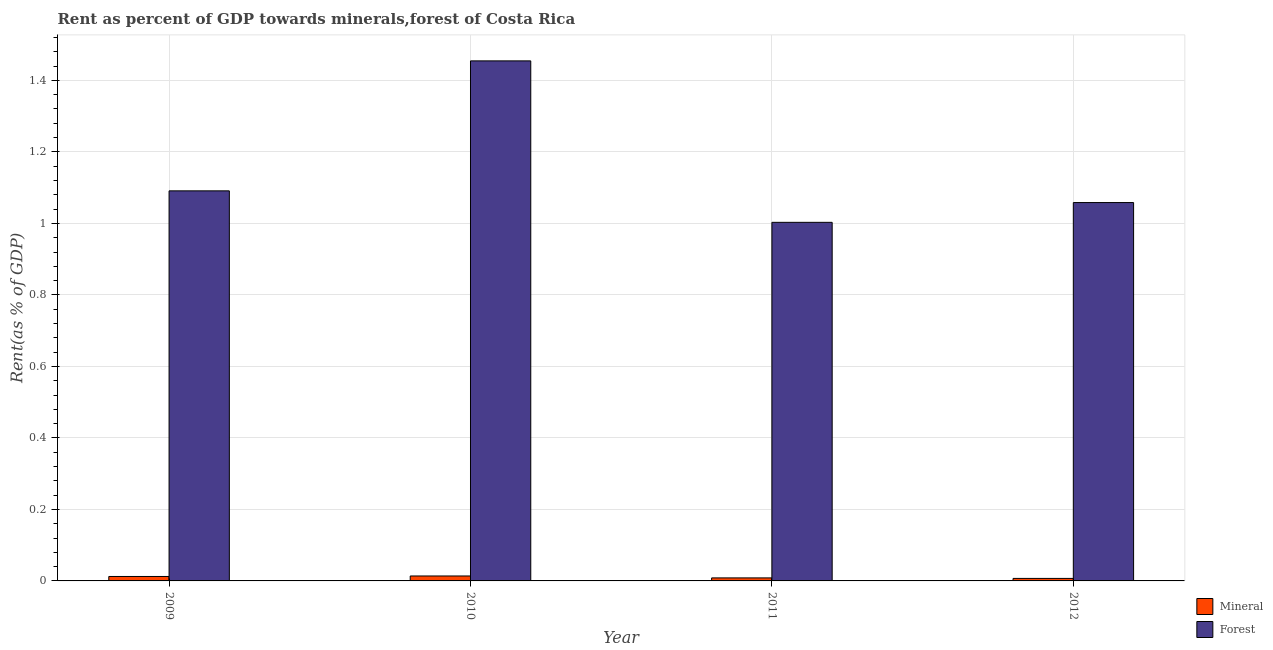How many groups of bars are there?
Your response must be concise. 4. Are the number of bars on each tick of the X-axis equal?
Provide a short and direct response. Yes. How many bars are there on the 2nd tick from the left?
Offer a very short reply. 2. How many bars are there on the 1st tick from the right?
Ensure brevity in your answer.  2. What is the label of the 4th group of bars from the left?
Offer a very short reply. 2012. What is the forest rent in 2012?
Your answer should be very brief. 1.06. Across all years, what is the maximum mineral rent?
Provide a short and direct response. 0.01. Across all years, what is the minimum mineral rent?
Your answer should be very brief. 0.01. In which year was the forest rent minimum?
Your answer should be compact. 2011. What is the total forest rent in the graph?
Provide a short and direct response. 4.61. What is the difference between the forest rent in 2010 and that in 2011?
Keep it short and to the point. 0.45. What is the difference between the forest rent in 2011 and the mineral rent in 2012?
Your answer should be very brief. -0.06. What is the average forest rent per year?
Your answer should be compact. 1.15. What is the ratio of the forest rent in 2009 to that in 2010?
Give a very brief answer. 0.75. Is the forest rent in 2010 less than that in 2012?
Provide a succinct answer. No. Is the difference between the forest rent in 2010 and 2011 greater than the difference between the mineral rent in 2010 and 2011?
Make the answer very short. No. What is the difference between the highest and the second highest mineral rent?
Make the answer very short. 0. What is the difference between the highest and the lowest mineral rent?
Offer a very short reply. 0.01. In how many years, is the mineral rent greater than the average mineral rent taken over all years?
Your answer should be compact. 2. What does the 1st bar from the left in 2009 represents?
Keep it short and to the point. Mineral. What does the 1st bar from the right in 2010 represents?
Provide a succinct answer. Forest. What is the difference between two consecutive major ticks on the Y-axis?
Ensure brevity in your answer.  0.2. Does the graph contain grids?
Offer a very short reply. Yes. Where does the legend appear in the graph?
Your answer should be very brief. Bottom right. How many legend labels are there?
Offer a very short reply. 2. How are the legend labels stacked?
Give a very brief answer. Vertical. What is the title of the graph?
Provide a succinct answer. Rent as percent of GDP towards minerals,forest of Costa Rica. What is the label or title of the X-axis?
Offer a very short reply. Year. What is the label or title of the Y-axis?
Your answer should be compact. Rent(as % of GDP). What is the Rent(as % of GDP) of Mineral in 2009?
Provide a short and direct response. 0.01. What is the Rent(as % of GDP) in Forest in 2009?
Your answer should be very brief. 1.09. What is the Rent(as % of GDP) in Mineral in 2010?
Offer a very short reply. 0.01. What is the Rent(as % of GDP) in Forest in 2010?
Your response must be concise. 1.45. What is the Rent(as % of GDP) in Mineral in 2011?
Offer a terse response. 0.01. What is the Rent(as % of GDP) of Forest in 2011?
Ensure brevity in your answer.  1. What is the Rent(as % of GDP) in Mineral in 2012?
Keep it short and to the point. 0.01. What is the Rent(as % of GDP) of Forest in 2012?
Offer a very short reply. 1.06. Across all years, what is the maximum Rent(as % of GDP) in Mineral?
Your answer should be very brief. 0.01. Across all years, what is the maximum Rent(as % of GDP) in Forest?
Your answer should be very brief. 1.45. Across all years, what is the minimum Rent(as % of GDP) of Mineral?
Your response must be concise. 0.01. Across all years, what is the minimum Rent(as % of GDP) in Forest?
Your response must be concise. 1. What is the total Rent(as % of GDP) of Mineral in the graph?
Make the answer very short. 0.04. What is the total Rent(as % of GDP) in Forest in the graph?
Make the answer very short. 4.61. What is the difference between the Rent(as % of GDP) in Mineral in 2009 and that in 2010?
Make the answer very short. -0. What is the difference between the Rent(as % of GDP) in Forest in 2009 and that in 2010?
Your answer should be compact. -0.36. What is the difference between the Rent(as % of GDP) in Mineral in 2009 and that in 2011?
Your answer should be compact. 0. What is the difference between the Rent(as % of GDP) of Forest in 2009 and that in 2011?
Give a very brief answer. 0.09. What is the difference between the Rent(as % of GDP) in Mineral in 2009 and that in 2012?
Make the answer very short. 0.01. What is the difference between the Rent(as % of GDP) in Forest in 2009 and that in 2012?
Your answer should be very brief. 0.03. What is the difference between the Rent(as % of GDP) of Mineral in 2010 and that in 2011?
Your answer should be very brief. 0.01. What is the difference between the Rent(as % of GDP) of Forest in 2010 and that in 2011?
Keep it short and to the point. 0.45. What is the difference between the Rent(as % of GDP) of Mineral in 2010 and that in 2012?
Your response must be concise. 0.01. What is the difference between the Rent(as % of GDP) of Forest in 2010 and that in 2012?
Your answer should be very brief. 0.4. What is the difference between the Rent(as % of GDP) of Mineral in 2011 and that in 2012?
Keep it short and to the point. 0. What is the difference between the Rent(as % of GDP) in Forest in 2011 and that in 2012?
Offer a very short reply. -0.06. What is the difference between the Rent(as % of GDP) of Mineral in 2009 and the Rent(as % of GDP) of Forest in 2010?
Offer a terse response. -1.44. What is the difference between the Rent(as % of GDP) in Mineral in 2009 and the Rent(as % of GDP) in Forest in 2011?
Offer a very short reply. -0.99. What is the difference between the Rent(as % of GDP) in Mineral in 2009 and the Rent(as % of GDP) in Forest in 2012?
Offer a terse response. -1.05. What is the difference between the Rent(as % of GDP) of Mineral in 2010 and the Rent(as % of GDP) of Forest in 2011?
Offer a very short reply. -0.99. What is the difference between the Rent(as % of GDP) in Mineral in 2010 and the Rent(as % of GDP) in Forest in 2012?
Keep it short and to the point. -1.04. What is the difference between the Rent(as % of GDP) in Mineral in 2011 and the Rent(as % of GDP) in Forest in 2012?
Provide a short and direct response. -1.05. What is the average Rent(as % of GDP) in Mineral per year?
Provide a succinct answer. 0.01. What is the average Rent(as % of GDP) in Forest per year?
Ensure brevity in your answer.  1.15. In the year 2009, what is the difference between the Rent(as % of GDP) in Mineral and Rent(as % of GDP) in Forest?
Your response must be concise. -1.08. In the year 2010, what is the difference between the Rent(as % of GDP) of Mineral and Rent(as % of GDP) of Forest?
Your response must be concise. -1.44. In the year 2011, what is the difference between the Rent(as % of GDP) in Mineral and Rent(as % of GDP) in Forest?
Ensure brevity in your answer.  -0.99. In the year 2012, what is the difference between the Rent(as % of GDP) in Mineral and Rent(as % of GDP) in Forest?
Ensure brevity in your answer.  -1.05. What is the ratio of the Rent(as % of GDP) in Mineral in 2009 to that in 2010?
Your answer should be compact. 0.9. What is the ratio of the Rent(as % of GDP) in Forest in 2009 to that in 2010?
Your answer should be very brief. 0.75. What is the ratio of the Rent(as % of GDP) of Mineral in 2009 to that in 2011?
Your answer should be compact. 1.47. What is the ratio of the Rent(as % of GDP) of Forest in 2009 to that in 2011?
Make the answer very short. 1.09. What is the ratio of the Rent(as % of GDP) in Mineral in 2009 to that in 2012?
Your answer should be very brief. 1.78. What is the ratio of the Rent(as % of GDP) in Forest in 2009 to that in 2012?
Provide a succinct answer. 1.03. What is the ratio of the Rent(as % of GDP) of Mineral in 2010 to that in 2011?
Make the answer very short. 1.63. What is the ratio of the Rent(as % of GDP) of Forest in 2010 to that in 2011?
Your answer should be compact. 1.45. What is the ratio of the Rent(as % of GDP) of Mineral in 2010 to that in 2012?
Provide a short and direct response. 1.97. What is the ratio of the Rent(as % of GDP) of Forest in 2010 to that in 2012?
Provide a succinct answer. 1.37. What is the ratio of the Rent(as % of GDP) in Mineral in 2011 to that in 2012?
Offer a very short reply. 1.21. What is the ratio of the Rent(as % of GDP) in Forest in 2011 to that in 2012?
Offer a very short reply. 0.95. What is the difference between the highest and the second highest Rent(as % of GDP) in Mineral?
Your response must be concise. 0. What is the difference between the highest and the second highest Rent(as % of GDP) of Forest?
Ensure brevity in your answer.  0.36. What is the difference between the highest and the lowest Rent(as % of GDP) in Mineral?
Provide a succinct answer. 0.01. What is the difference between the highest and the lowest Rent(as % of GDP) in Forest?
Offer a very short reply. 0.45. 